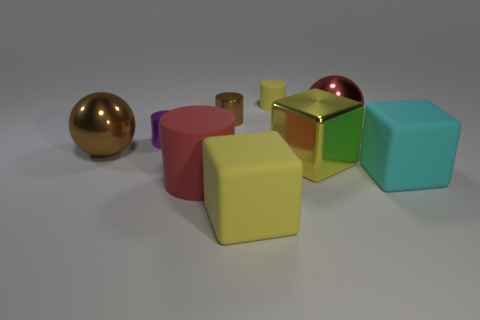Subtract all large metallic cubes. How many cubes are left? 2 Subtract 3 cylinders. How many cylinders are left? 1 Subtract all cyan cubes. How many cubes are left? 2 Add 1 tiny purple metal objects. How many objects exist? 10 Subtract all cylinders. How many objects are left? 5 Subtract all tiny brown metallic cylinders. Subtract all brown things. How many objects are left? 6 Add 5 brown metal cylinders. How many brown metal cylinders are left? 6 Add 3 big metal cubes. How many big metal cubes exist? 4 Subtract 0 gray spheres. How many objects are left? 9 Subtract all purple blocks. Subtract all green balls. How many blocks are left? 3 